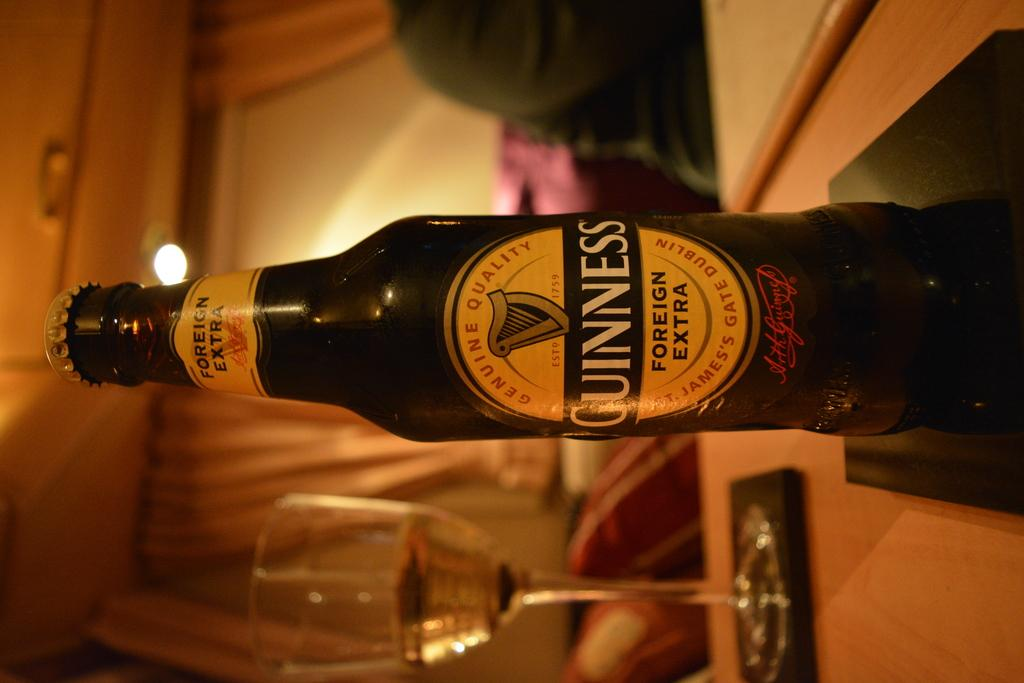<image>
Write a terse but informative summary of the picture. A bottle of Guinness beer is on top of a coaster next to a stemmed glass. 